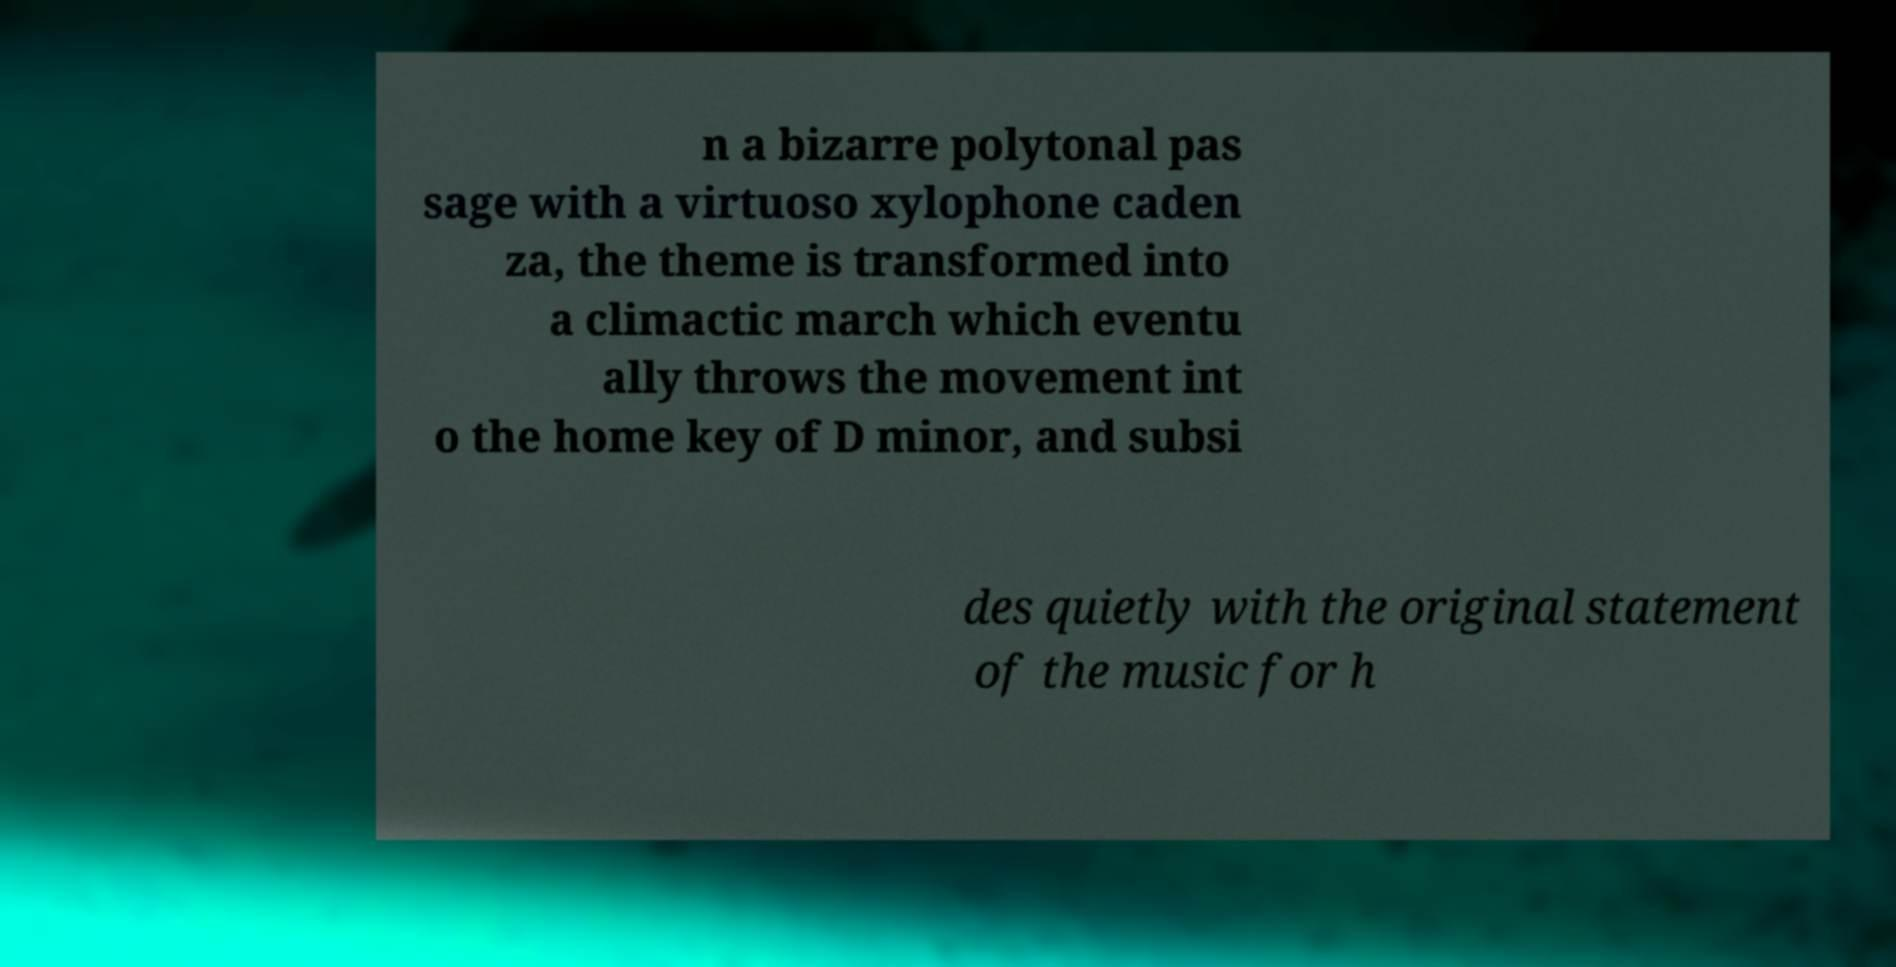Can you accurately transcribe the text from the provided image for me? n a bizarre polytonal pas sage with a virtuoso xylophone caden za, the theme is transformed into a climactic march which eventu ally throws the movement int o the home key of D minor, and subsi des quietly with the original statement of the music for h 